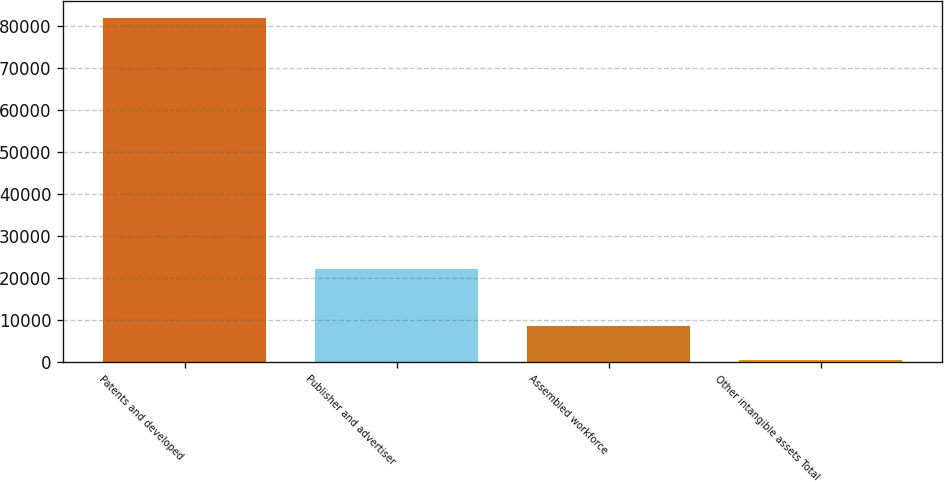Convert chart to OTSL. <chart><loc_0><loc_0><loc_500><loc_500><bar_chart><fcel>Patents and developed<fcel>Publisher and advertiser<fcel>Assembled workforce<fcel>Other intangible assets Total<nl><fcel>81887<fcel>22169<fcel>8595.5<fcel>452<nl></chart> 